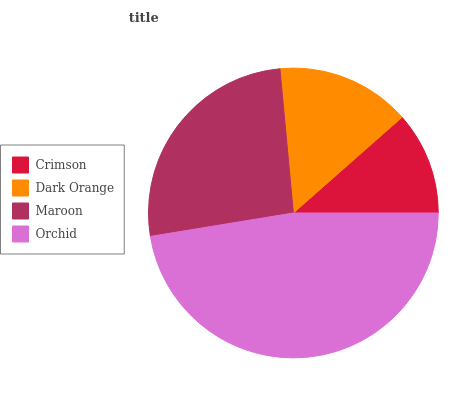Is Crimson the minimum?
Answer yes or no. Yes. Is Orchid the maximum?
Answer yes or no. Yes. Is Dark Orange the minimum?
Answer yes or no. No. Is Dark Orange the maximum?
Answer yes or no. No. Is Dark Orange greater than Crimson?
Answer yes or no. Yes. Is Crimson less than Dark Orange?
Answer yes or no. Yes. Is Crimson greater than Dark Orange?
Answer yes or no. No. Is Dark Orange less than Crimson?
Answer yes or no. No. Is Maroon the high median?
Answer yes or no. Yes. Is Dark Orange the low median?
Answer yes or no. Yes. Is Orchid the high median?
Answer yes or no. No. Is Orchid the low median?
Answer yes or no. No. 